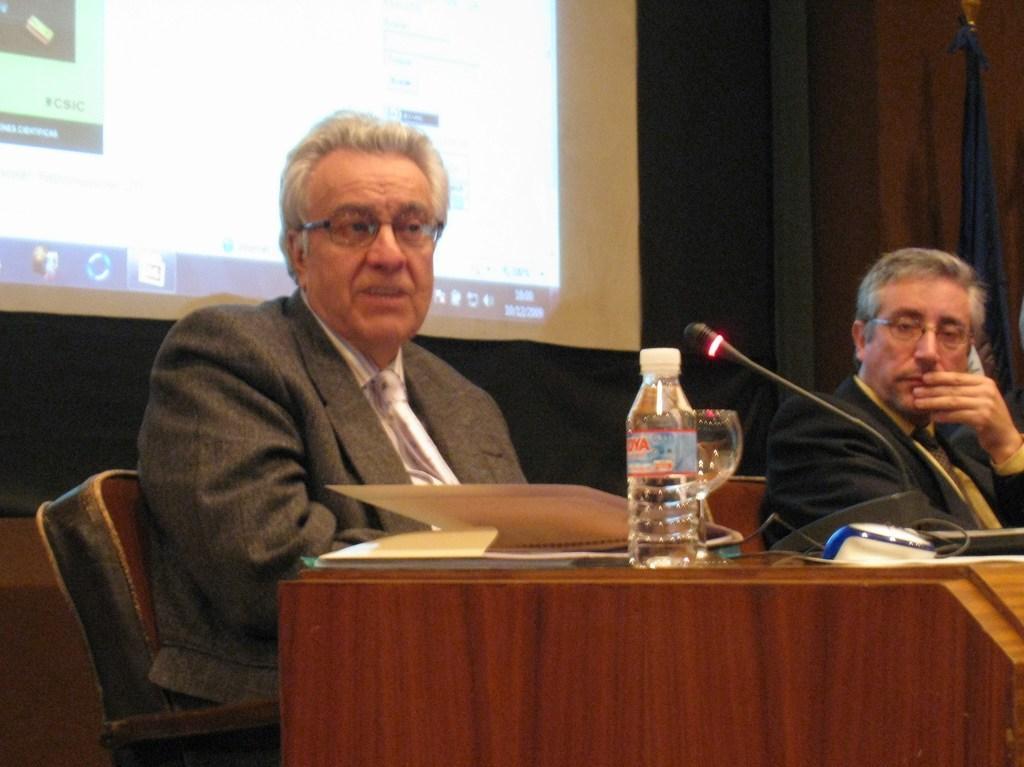In one or two sentences, can you explain what this image depicts? This picture is of inside the room. On the right there is a table on the top of a glass, a bottle, a book and a microphone is placed. On the right there is a man wearing a black color suit and sitting on the chair. In the center there is a man wearing a suit, sitting on the chair and seems to be talking. In the background we can see a flag, a wall and a projector screen. 